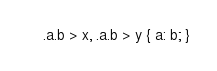<code> <loc_0><loc_0><loc_500><loc_500><_CSS_>.a.b > x, .a.b > y { a: b; }
</code> 